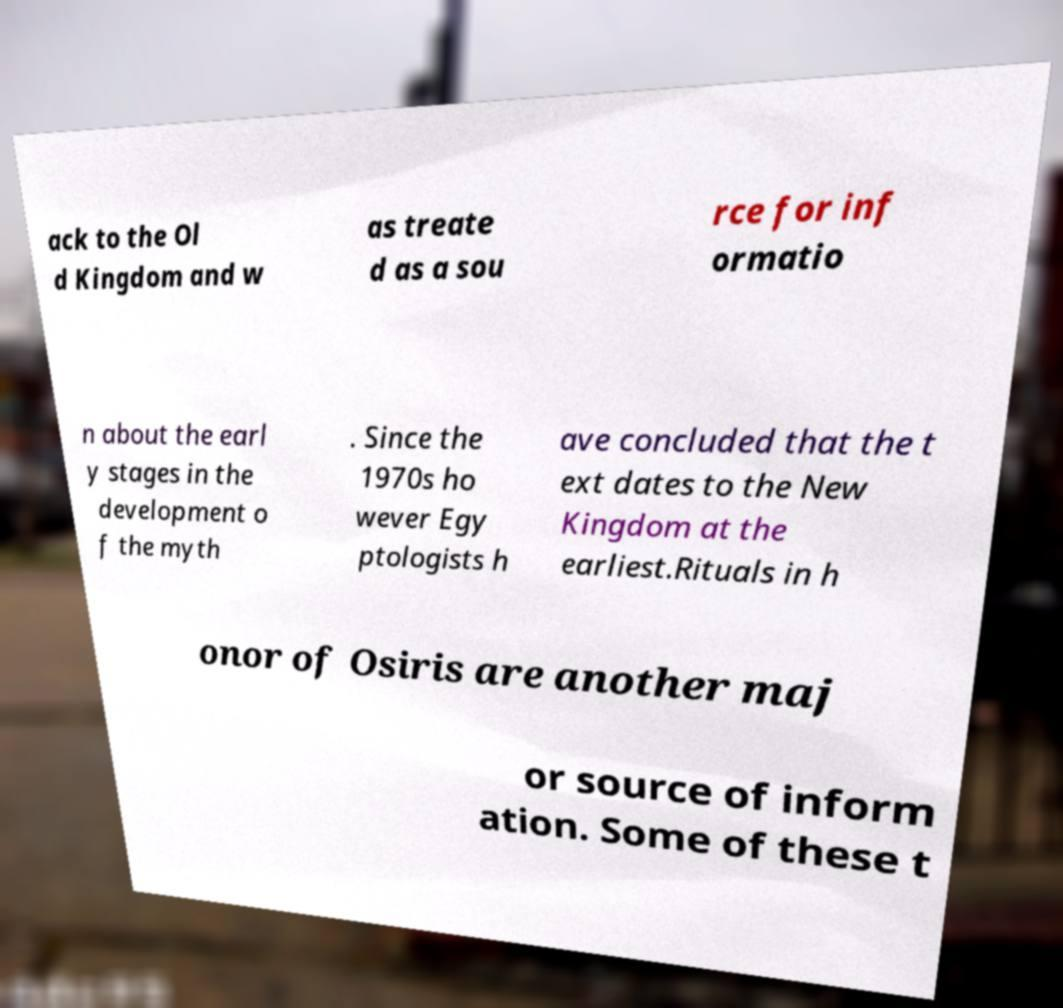Please identify and transcribe the text found in this image. ack to the Ol d Kingdom and w as treate d as a sou rce for inf ormatio n about the earl y stages in the development o f the myth . Since the 1970s ho wever Egy ptologists h ave concluded that the t ext dates to the New Kingdom at the earliest.Rituals in h onor of Osiris are another maj or source of inform ation. Some of these t 